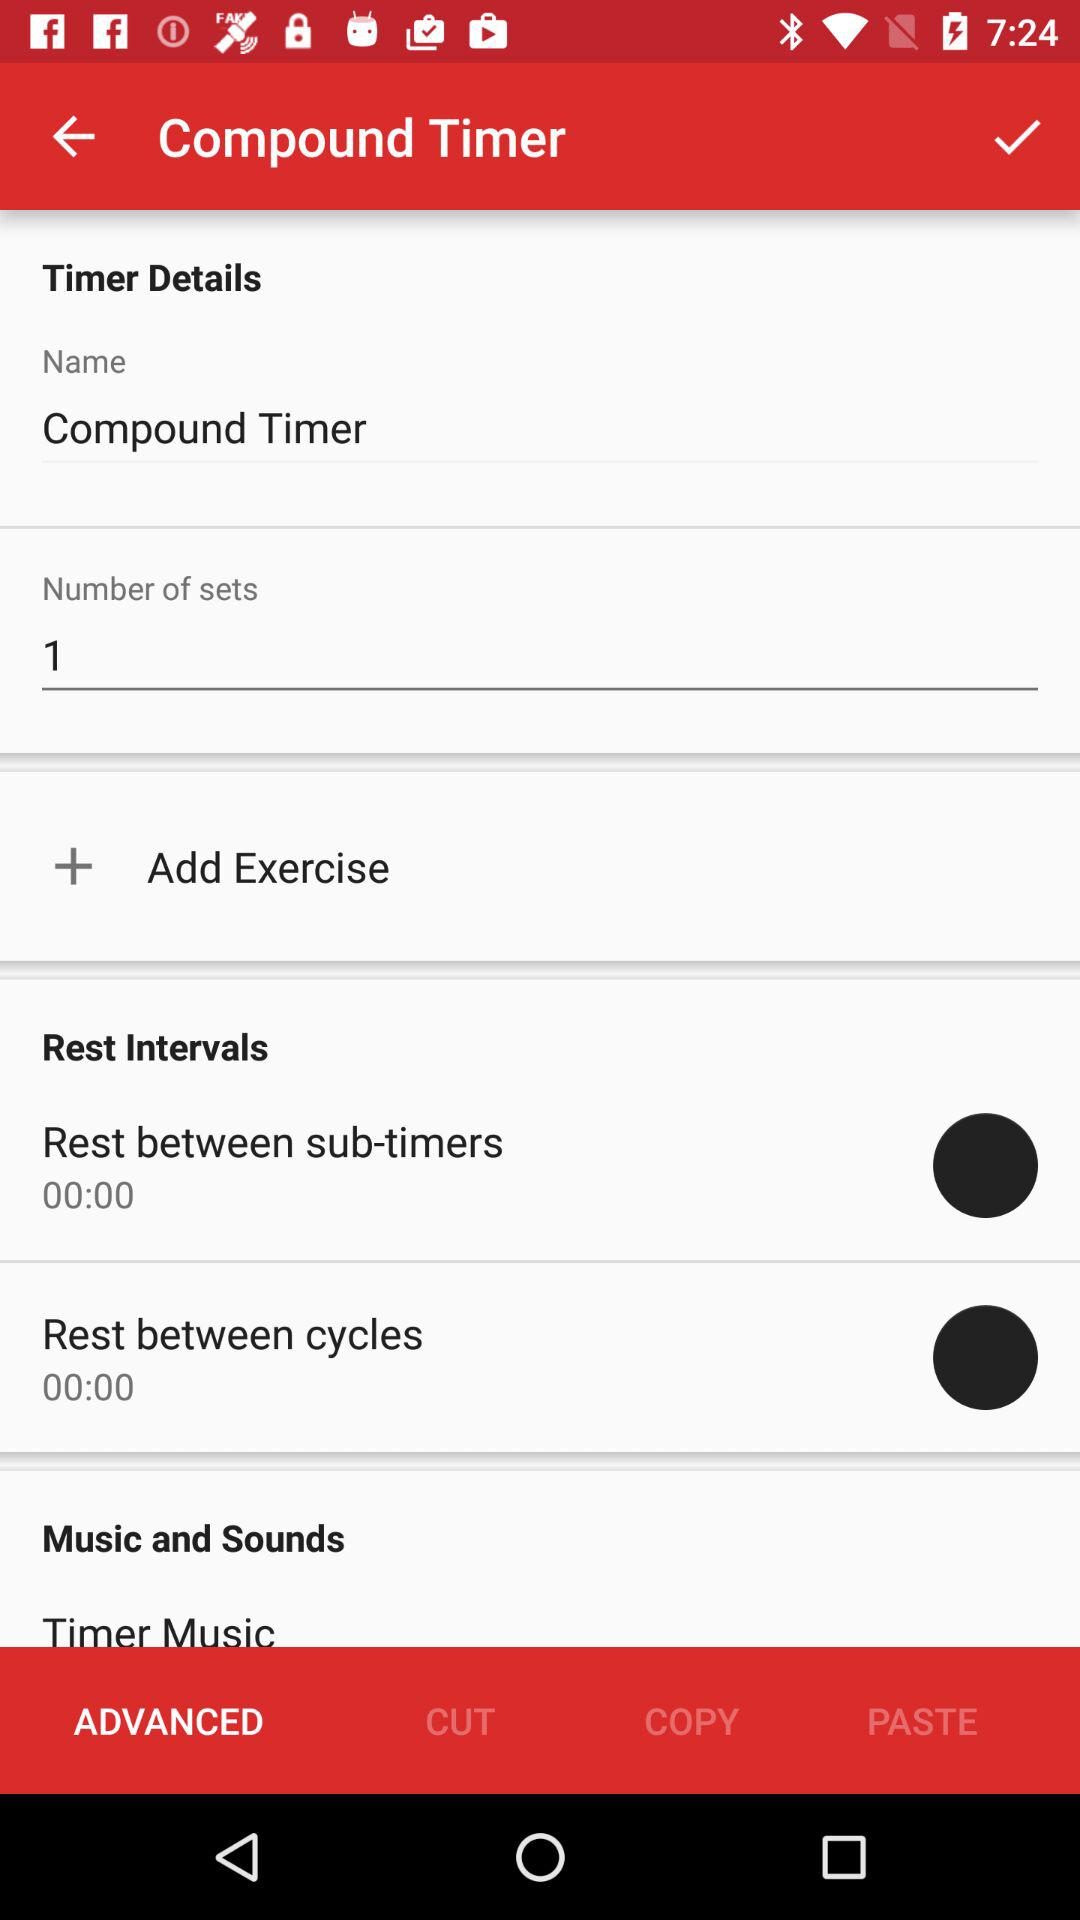What is the name of the timer? The name of the timer is "Compound Timer". 